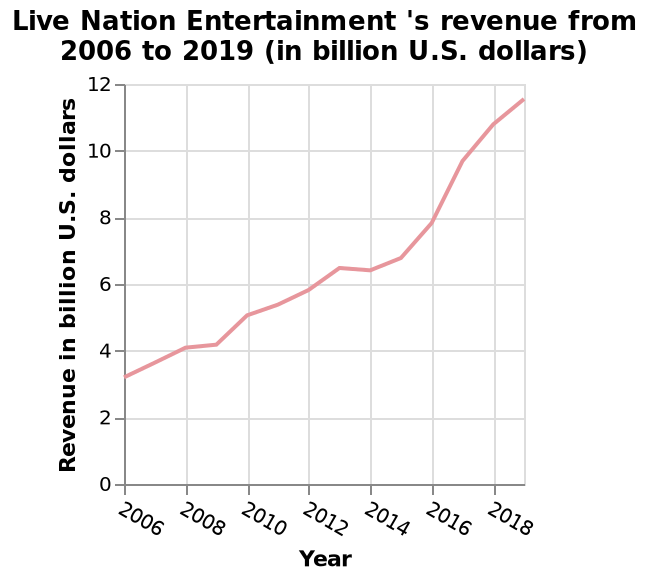<image>
please enumerates aspects of the construction of the chart Live Nation Entertainment 's revenue from 2006 to 2019 (in billion U.S. dollars) is a line plot. The x-axis shows Year. Along the y-axis, Revenue in billion U.S. dollars is defined. What year had the highest revenue for Live Nation Entertainment? The line plot does not provide information about the specific year with the highest revenue for Live Nation Entertainment. Was the increase in revenue after 2014 significant?  Yes, there was quite a sharp increase after 2014. Does the line plot provide accurate information about the specific year with the highest revenue for Live Nation Entertainment? No.The line plot does not provide information about the specific year with the highest revenue for Live Nation Entertainment. 